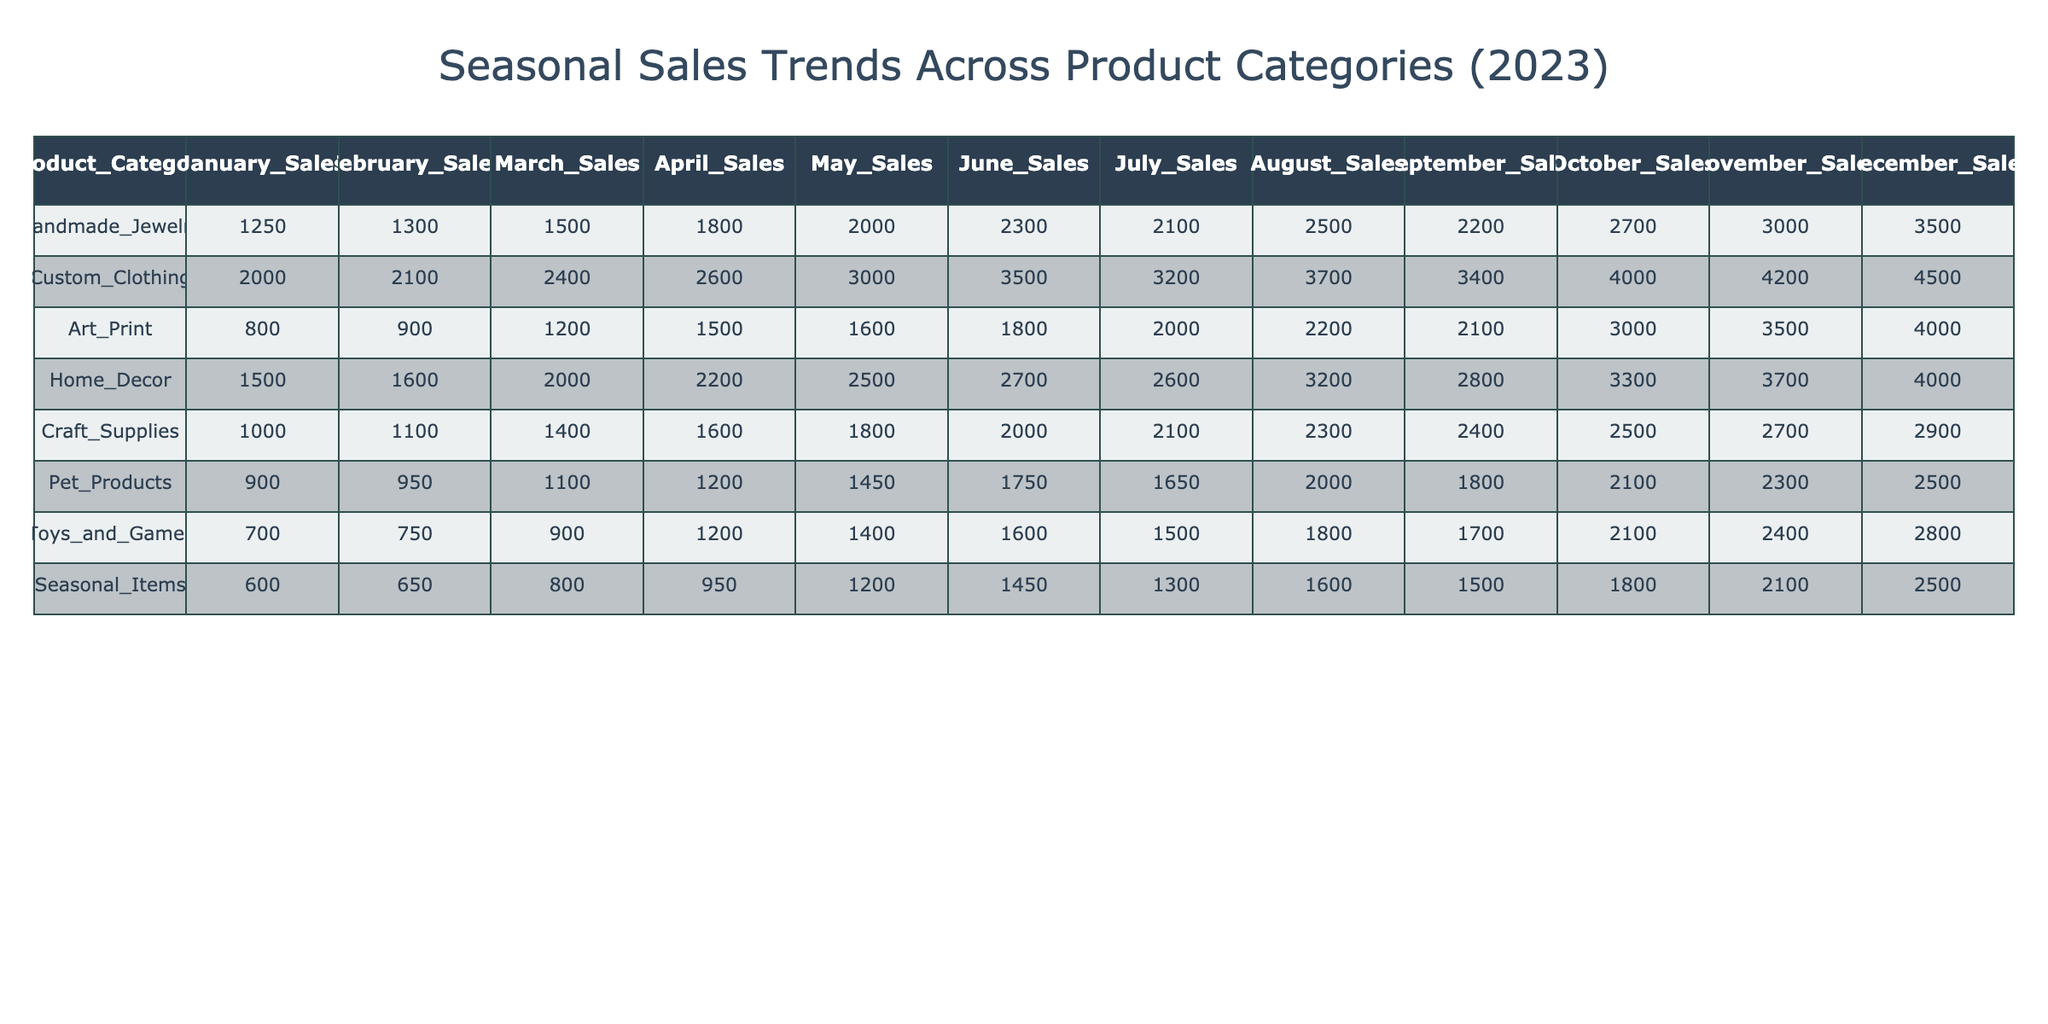What was the highest sales month for Handmade Jewelry in 2023? Looking at the sales for Handmade Jewelry, the values show that December had the highest sales amount of 3500.
Answer: 3500 Which product category had the lowest sales in July? By reviewing the July sales across all product categories, the category with the lowest sales is Toys and Games, which sold 1500 units.
Answer: 1500 What is the total sales for Custom Clothing from January to June? To find the total sales for Custom Clothing from January to June, we sum the sales from these months: 2000 + 2100 + 2400 + 2600 + 3000 + 3500 = 18600.
Answer: 18600 Did Craft Supplies see an increase in sales every month from January to June? Analyzing Craft Supplies sales: January 1000, February 1100, March 1400, April 1600, May 1800, June 2000—since all values increase, the answer is yes.
Answer: Yes What is the average sales for Art Print in the second half of the year? The sales for Art Print from July to December are: 2000, 2200, 2100, 3000, 3500, 4000. Totaling these gives 2000 + 2200 + 2100 + 3000 + 3500 + 4000 = 16800. To find the average, divide by 6, which results in 2800.
Answer: 2800 Which product category had the highest sales during the holiday season (November and December)? Focusing on the sales for November and December: Handmade Jewelry (3000, 3500), Custom Clothing (4200, 4500), Home Decor (3700, 4000), Art Print (3500, 4000), Craft Supplies (2700, 2900), Pet Products (2300, 2500), Toys and Games (2400, 2800), Seasonal Items (2100, 2500). Custom Clothing recorded the highest sales totaling 8700.
Answer: 8700 What was the sales difference for Home Decor between April and September? The sales figures for Home Decor are 2200 in April and 2800 in September. The difference is 2800 - 2200 = 600.
Answer: 600 Is it true that Pet Products had more sales in June than in March? In the sales table, Pet Products show 1750 in June and 1100 in March, meaning June had more sales. Therefore, this statement is true.
Answer: Yes What is the sum of sales for Seasonal Items in the first quarter of the year? In the first quarter for Seasonal Items, the sales are: January 600, February 650, March 800. Summing these values gives 600 + 650 + 800 = 2050.
Answer: 2050 